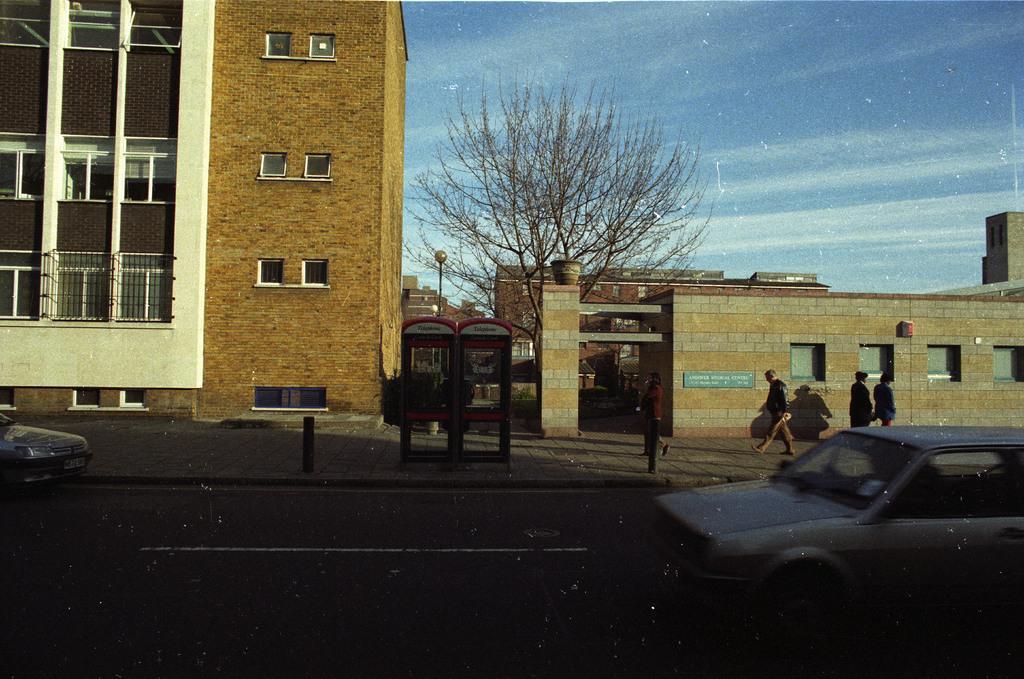Can you describe this image briefly? In this picture we can see the brown building and dry tree. In the front bottom side there are some cars on the road. 